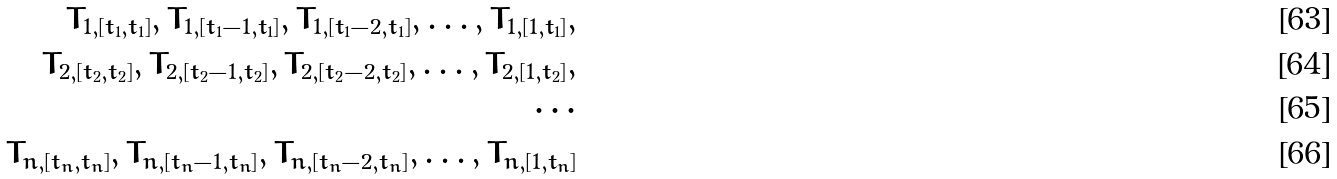<formula> <loc_0><loc_0><loc_500><loc_500>T _ { 1 , [ t _ { 1 } , t _ { 1 } ] } , T _ { 1 , [ t _ { 1 } - 1 , t _ { 1 } ] } , T _ { 1 , [ t _ { 1 } - 2 , t _ { 1 } ] } , \dots , T _ { 1 , [ 1 , t _ { 1 } ] } , \\ T _ { 2 , [ t _ { 2 } , t _ { 2 } ] } , T _ { 2 , [ t _ { 2 } - 1 , t _ { 2 } ] } , T _ { 2 , [ t _ { 2 } - 2 , t _ { 2 } ] } , \dots , T _ { 2 , [ 1 , t _ { 2 } ] } , \\ \cdots \\ T _ { n , [ t _ { n } , t _ { n } ] } , T _ { n , [ t _ { n } - 1 , t _ { n } ] } , T _ { n , [ t _ { n } - 2 , t _ { n } ] } , \dots , T _ { n , [ 1 , t _ { n } ] }</formula> 